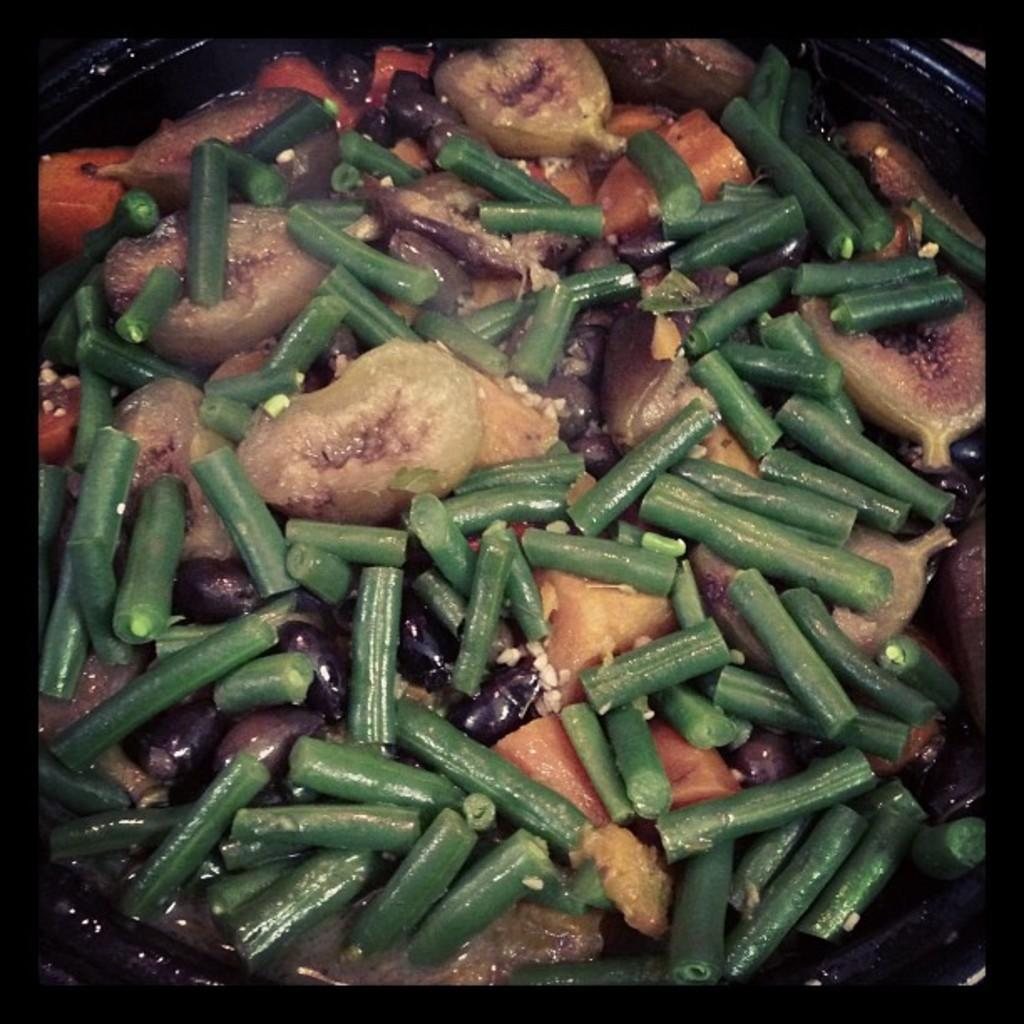What is located in the picture? There is a bowl in the picture. What is inside the bowl? There are vegetables in the bowl. What type of book can be seen in the picture? There is no book present in the picture; it only features a bowl with vegetables. 